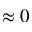Convert formula to latex. <formula><loc_0><loc_0><loc_500><loc_500>\approx 0</formula> 